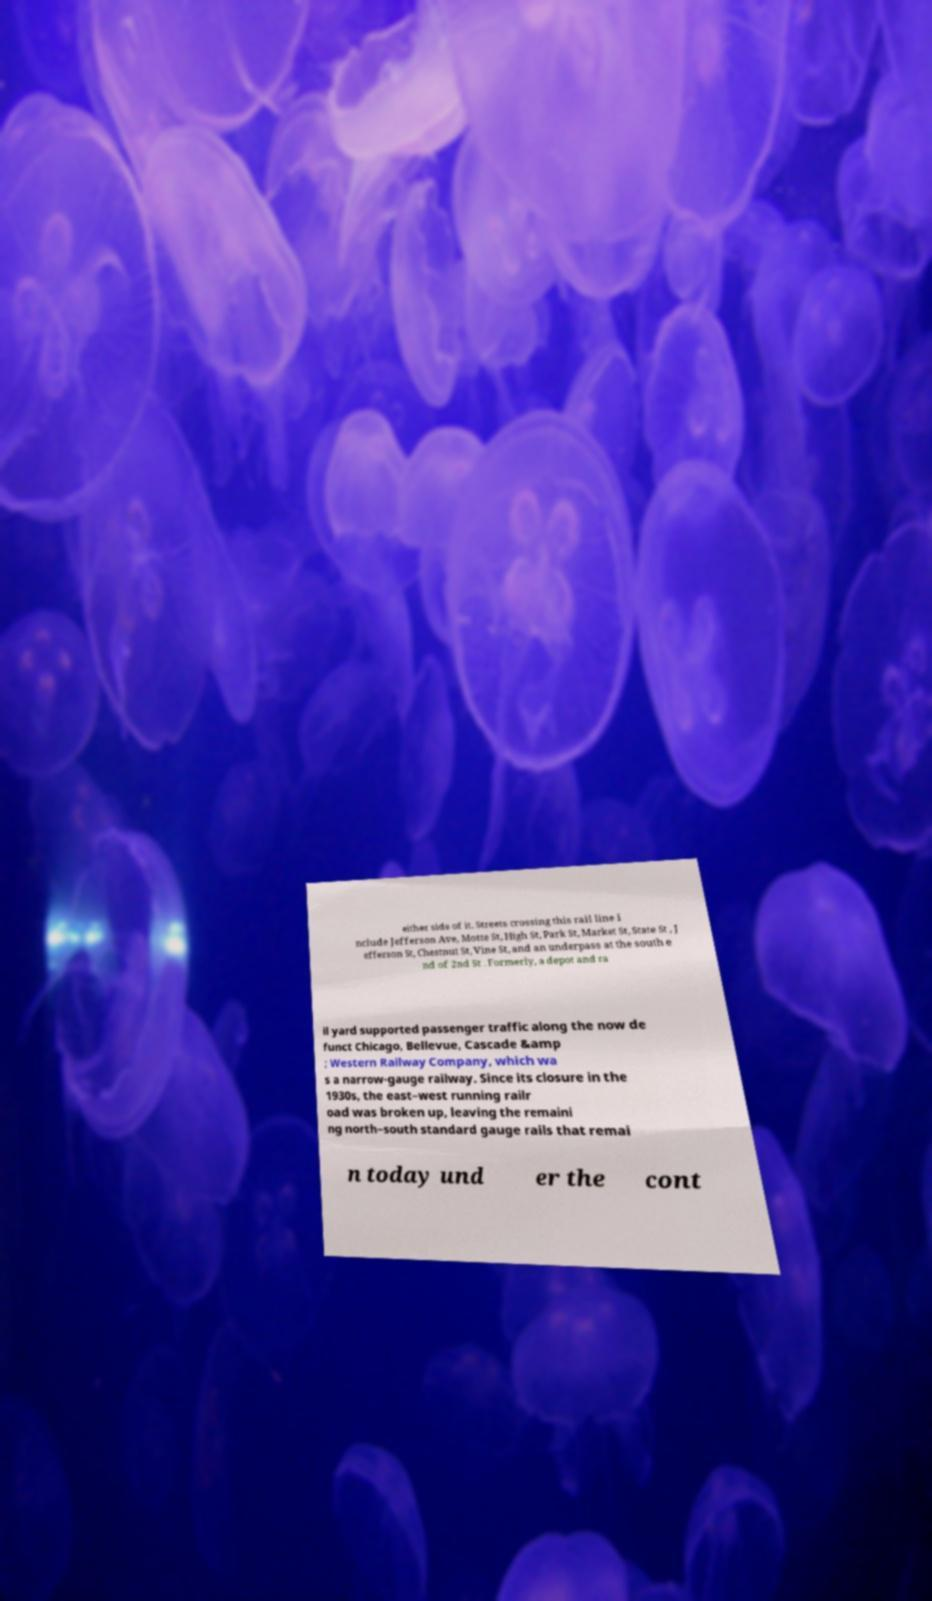Can you accurately transcribe the text from the provided image for me? either side of it. Streets crossing this rail line i nclude Jefferson Ave, Motte St, High St, Park St, Market St, State St , J efferson St, Chestnut St, Vine St, and an underpass at the south e nd of 2nd St . Formerly, a depot and ra il yard supported passenger traffic along the now de funct Chicago, Bellevue, Cascade &amp ; Western Railway Company, which wa s a narrow-gauge railway. Since its closure in the 1930s, the east–west running railr oad was broken up, leaving the remaini ng north–south standard gauge rails that remai n today und er the cont 